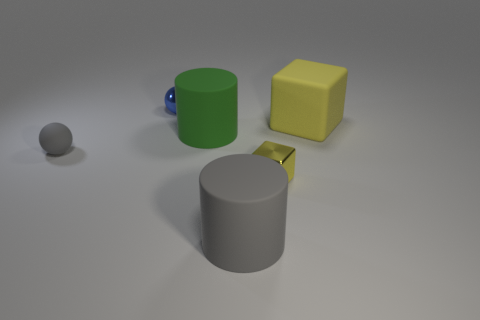Add 2 yellow rubber blocks. How many objects exist? 8 Subtract all spheres. How many objects are left? 4 Add 2 gray objects. How many gray objects are left? 4 Add 2 tiny gray matte things. How many tiny gray matte things exist? 3 Subtract 0 green blocks. How many objects are left? 6 Subtract all large red metallic spheres. Subtract all metal things. How many objects are left? 4 